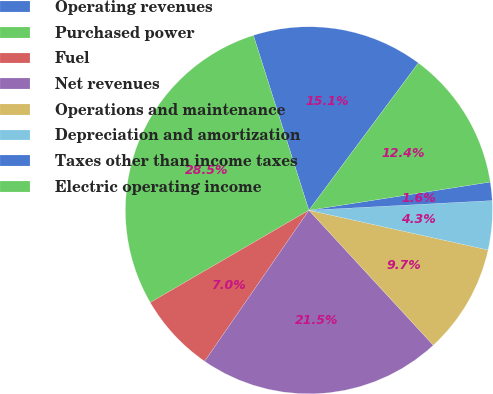Convert chart. <chart><loc_0><loc_0><loc_500><loc_500><pie_chart><fcel>Operating revenues<fcel>Purchased power<fcel>Fuel<fcel>Net revenues<fcel>Operations and maintenance<fcel>Depreciation and amortization<fcel>Taxes other than income taxes<fcel>Electric operating income<nl><fcel>15.06%<fcel>28.49%<fcel>7.0%<fcel>21.47%<fcel>9.68%<fcel>4.31%<fcel>1.62%<fcel>12.37%<nl></chart> 